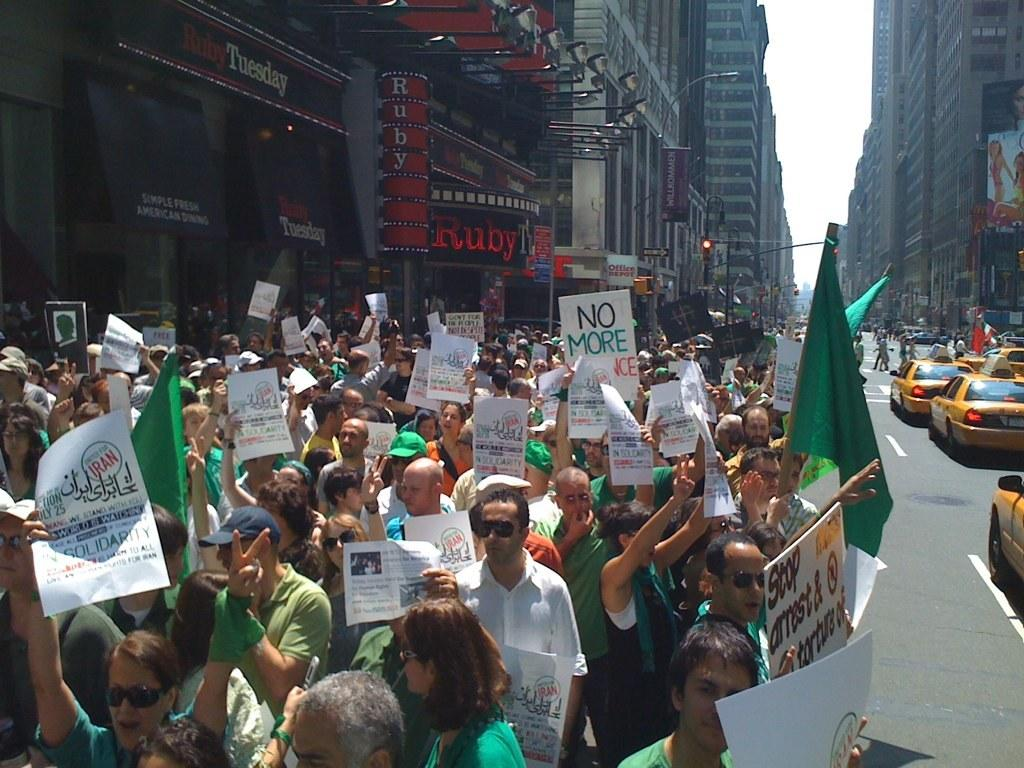<image>
Share a concise interpretation of the image provided. A group of protesters are outside of Ruby Tuesday. 